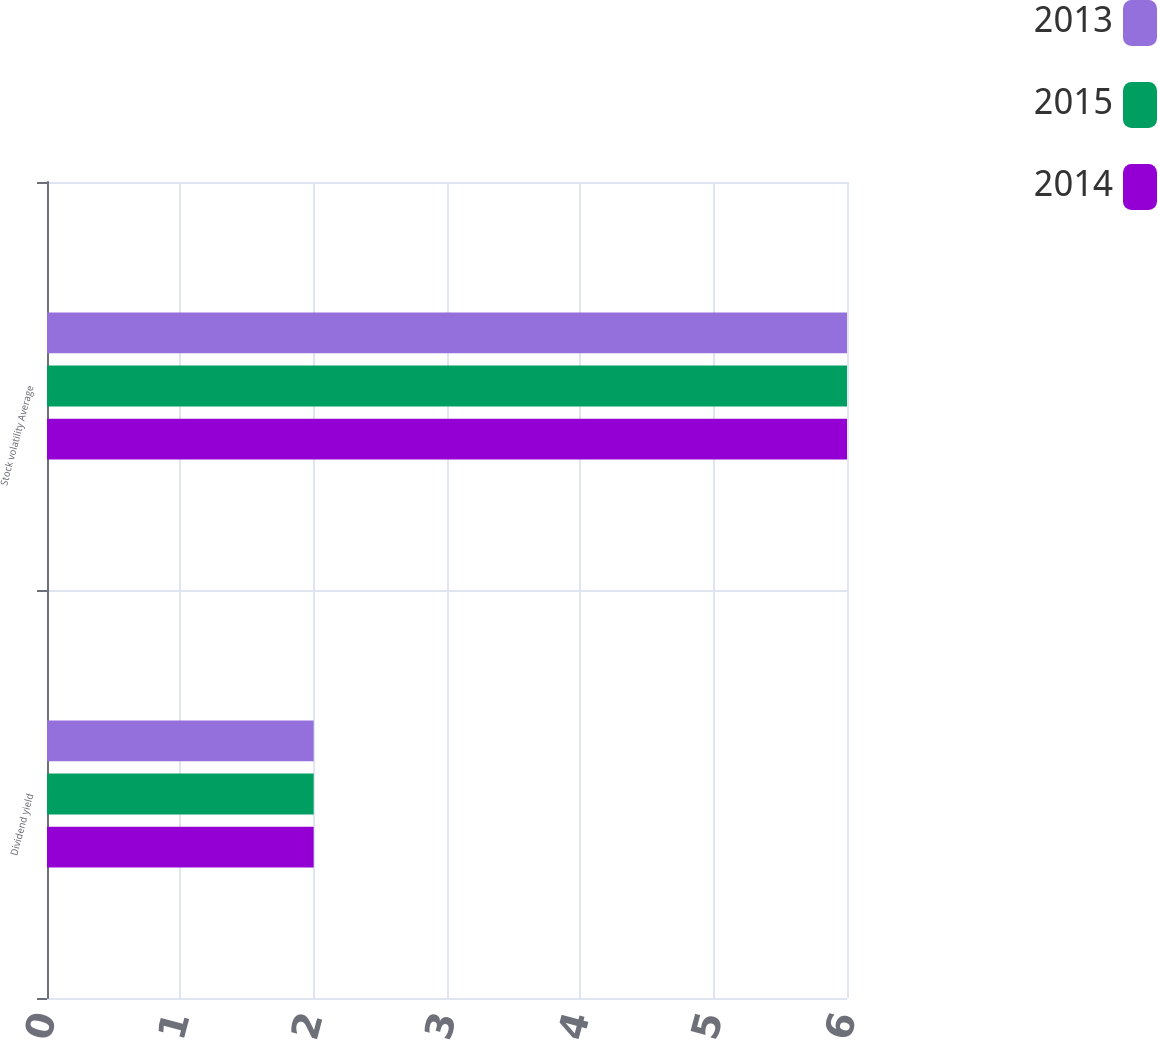Convert chart to OTSL. <chart><loc_0><loc_0><loc_500><loc_500><stacked_bar_chart><ecel><fcel>Dividend yield<fcel>Stock volatility Average<nl><fcel>2013<fcel>2<fcel>6<nl><fcel>2015<fcel>2<fcel>6<nl><fcel>2014<fcel>2<fcel>6<nl></chart> 